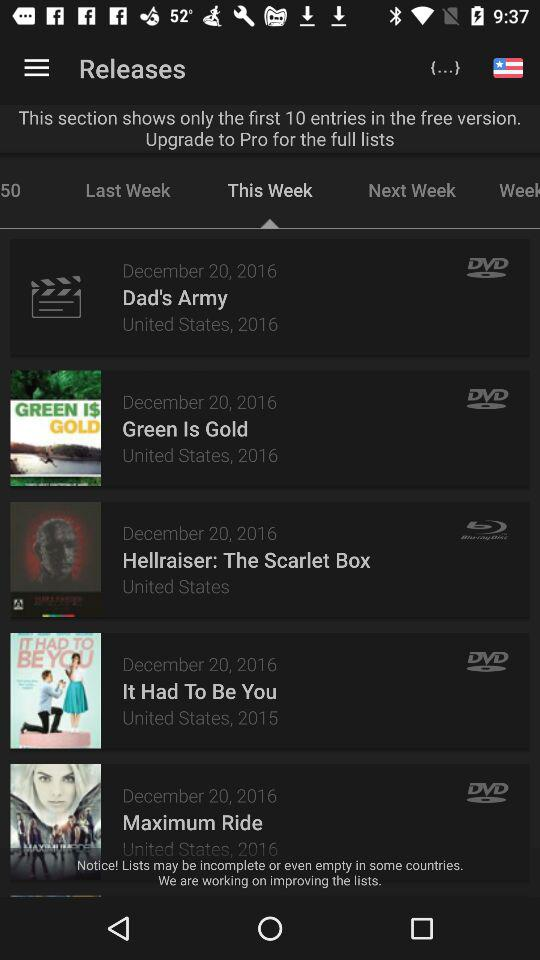Which tab is currently selected? The currently selected tab is "This Week". 